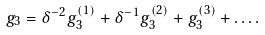Convert formula to latex. <formula><loc_0><loc_0><loc_500><loc_500>g _ { 3 } = \delta ^ { - 2 } g _ { 3 } ^ { ( 1 ) } + \delta ^ { - 1 } g _ { 3 } ^ { ( 2 ) } + g _ { 3 } ^ { ( 3 ) } + \dots .</formula> 